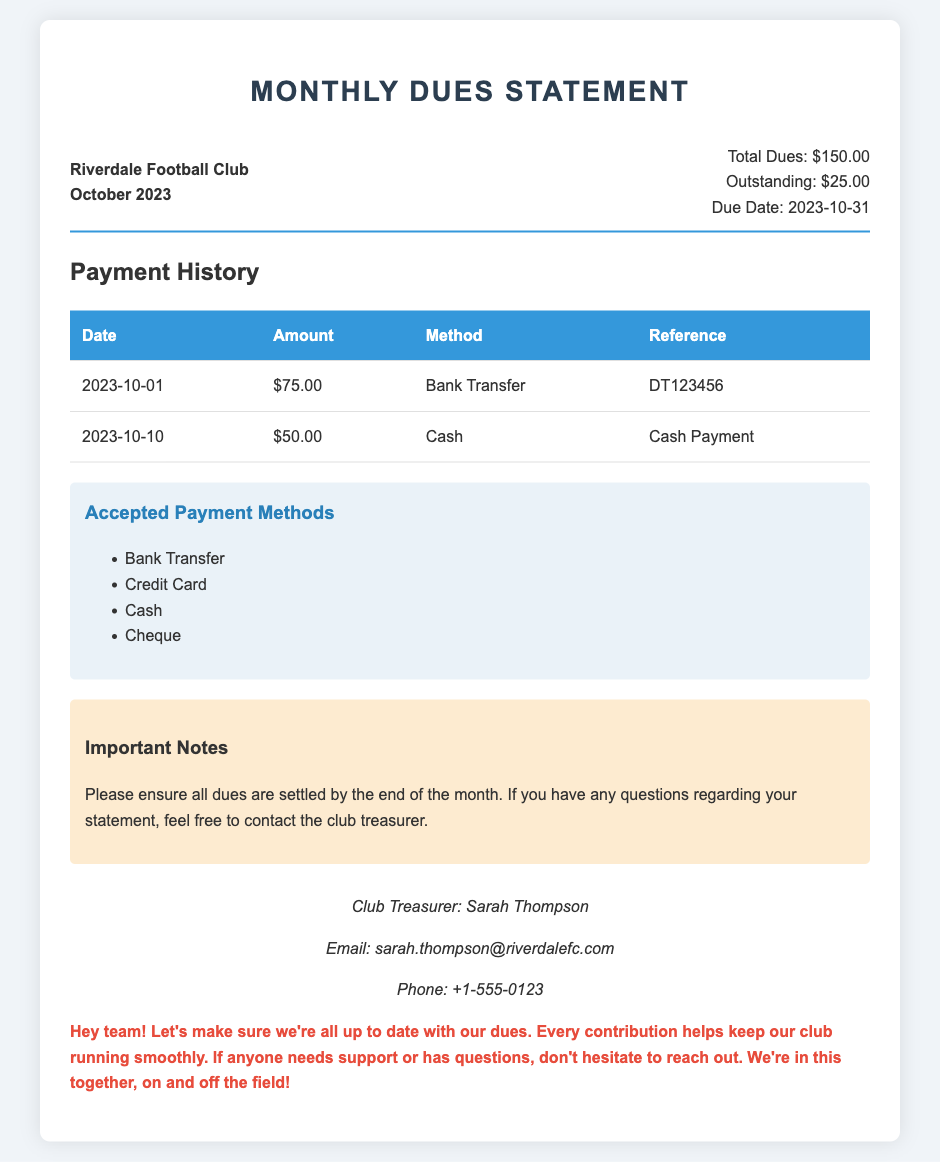What is the total dues for October 2023? The total dues for October 2023 are mentioned in the statement as $150.00.
Answer: $150.00 What is the outstanding balance? The outstanding balance is specified in the statement and is $25.00.
Answer: $25.00 When is the due date for the dues? The due date is clearly stated in the document as October 31, 2023.
Answer: 2023-10-31 How much was paid on October 1, 2023? The payment made on October 1, 2023, is listed as $75.00 in the payment history.
Answer: $75.00 What payment method was used for the October 10 payment? The payment method for the October 10 payment is identified as Cash.
Answer: Cash Who is the club treasurer? The name of the club treasurer is provided as Sarah Thompson.
Answer: Sarah Thompson What should members ensure according to the important notes? The important notes state that all dues should be settled by the end of the month.
Answer: Settled by the end of the month How many payments have been made this month? The document lists a total of two payments made this month in the payment history section.
Answer: Two What are the accepted payment methods? The accepted payment methods are detailed in a list, including Bank Transfer, Credit Card, Cash, and Cheque.
Answer: Bank Transfer, Credit Card, Cash, Cheque 